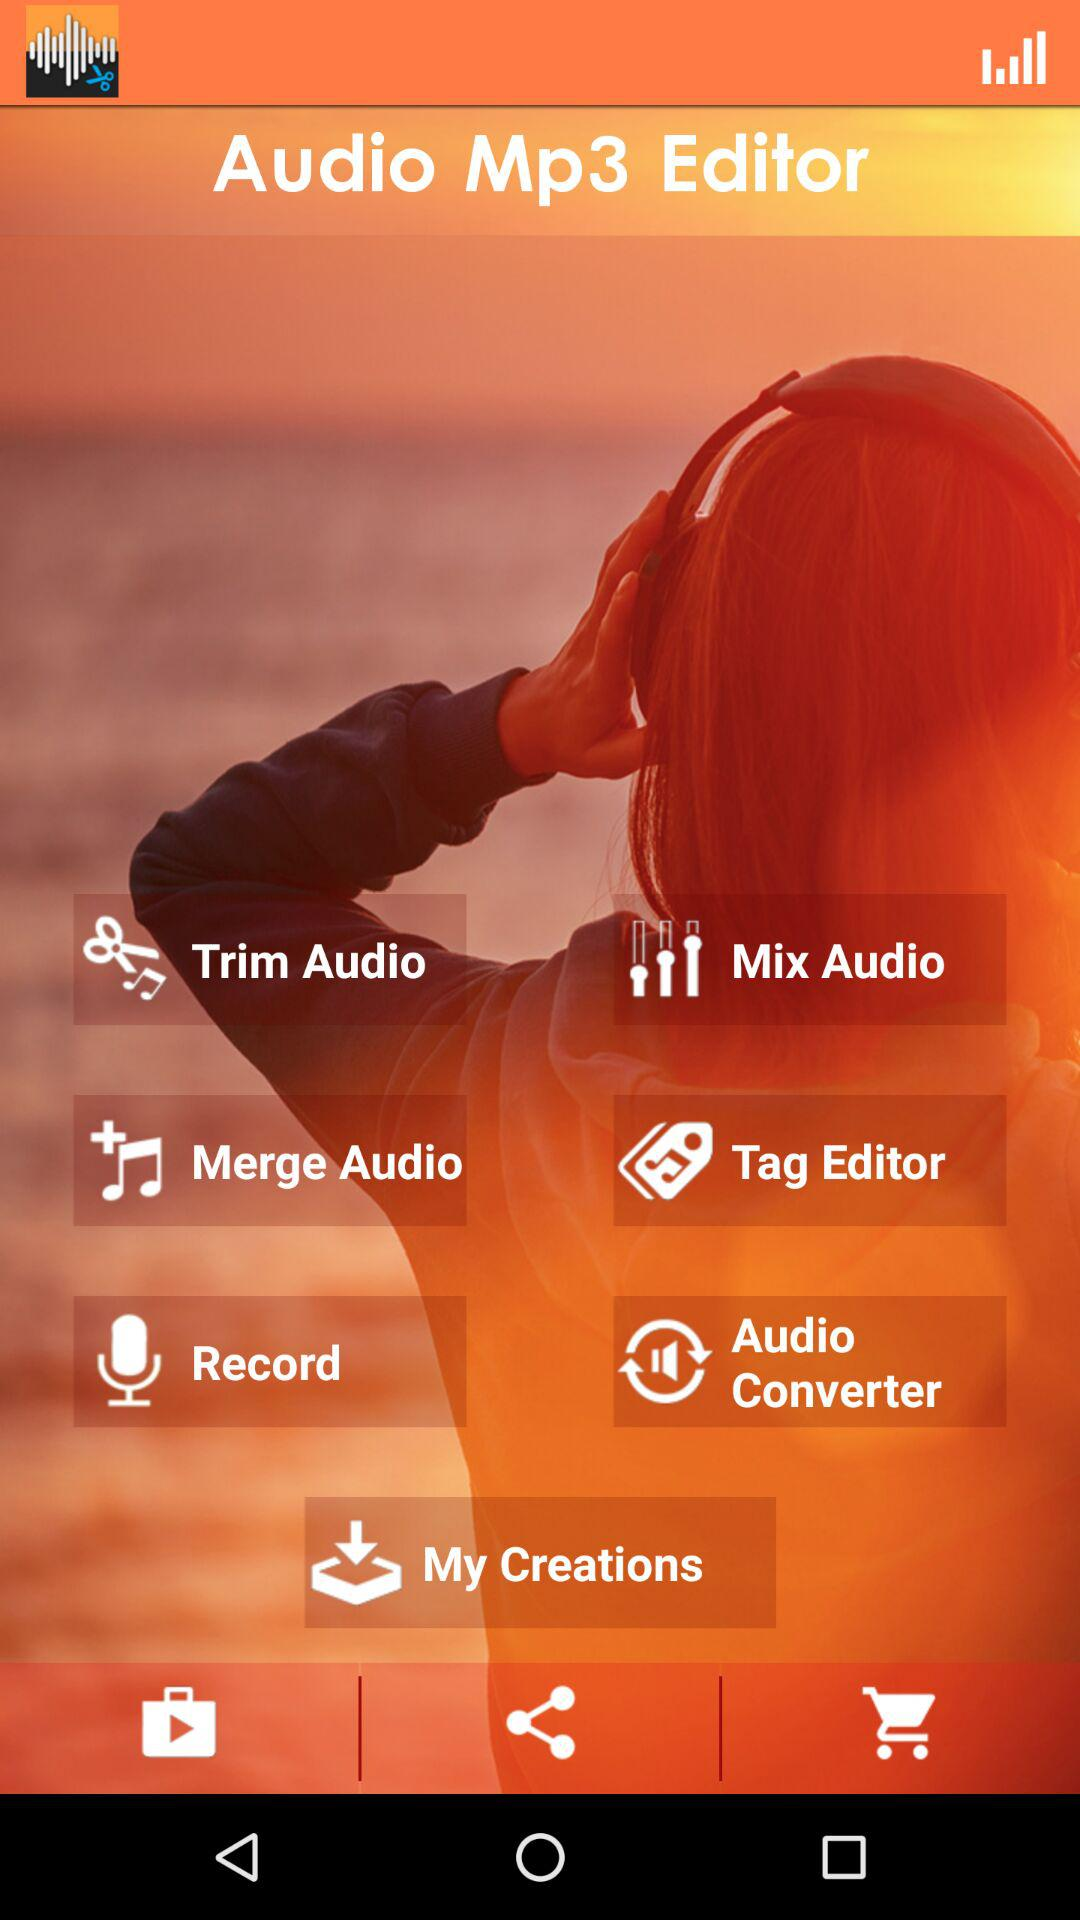What is the application name? The application name is "Audio Mp3 Editor". 